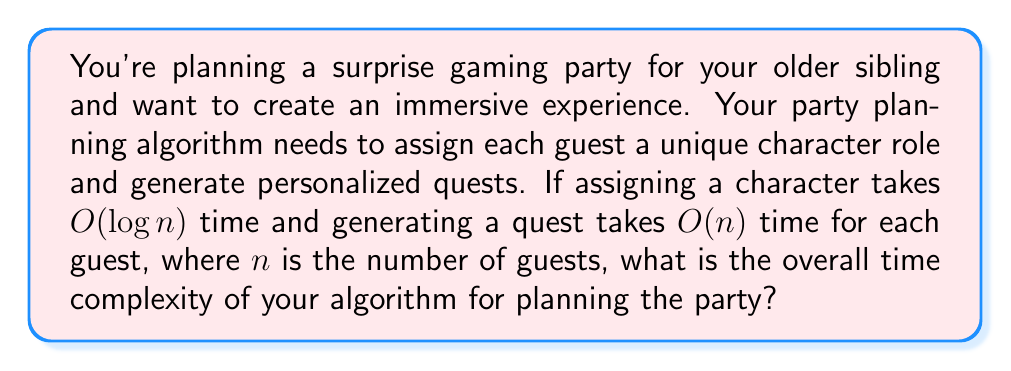Can you answer this question? Let's break this down step-by-step:

1) First, we need to assign a character to each guest:
   - This takes $O(log n)$ time per guest
   - We do this for all $n$ guests
   - So, the total time for character assignment is $O(n log n)$

2) Next, we generate a quest for each guest:
   - This takes $O(n)$ time per guest
   - We do this for all $n$ guests
   - So, the total time for quest generation is $O(n^2)$

3) To find the overall time complexity, we add these together:
   $O(n log n) + O(n^2)$

4) In asymptotic analysis, we only keep the term that grows the fastest as $n$ increases. Between $n log n$ and $n^2$, $n^2$ grows faster for large $n$.

Therefore, the overall time complexity of the algorithm is $O(n^2)$.
Answer: $O(n^2)$ 